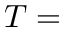<formula> <loc_0><loc_0><loc_500><loc_500>T =</formula> 